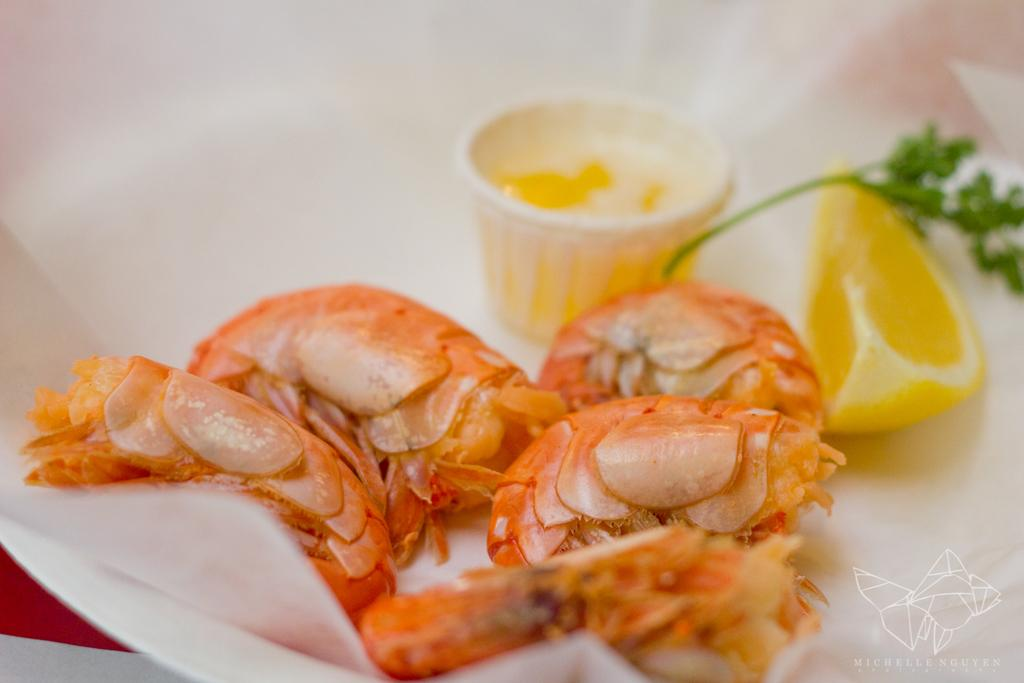What type of seafood is present in the image? There are prawns in the image. Where are the prawns located? The prawns are in a plate. How many boats can be seen in the harbor in the image? There is no harbor or boats present in the image; it features prawns in a plate. What rule is being enforced by the boy in the image? There is no boy or rule present in the image; it features prawns in a plate. 